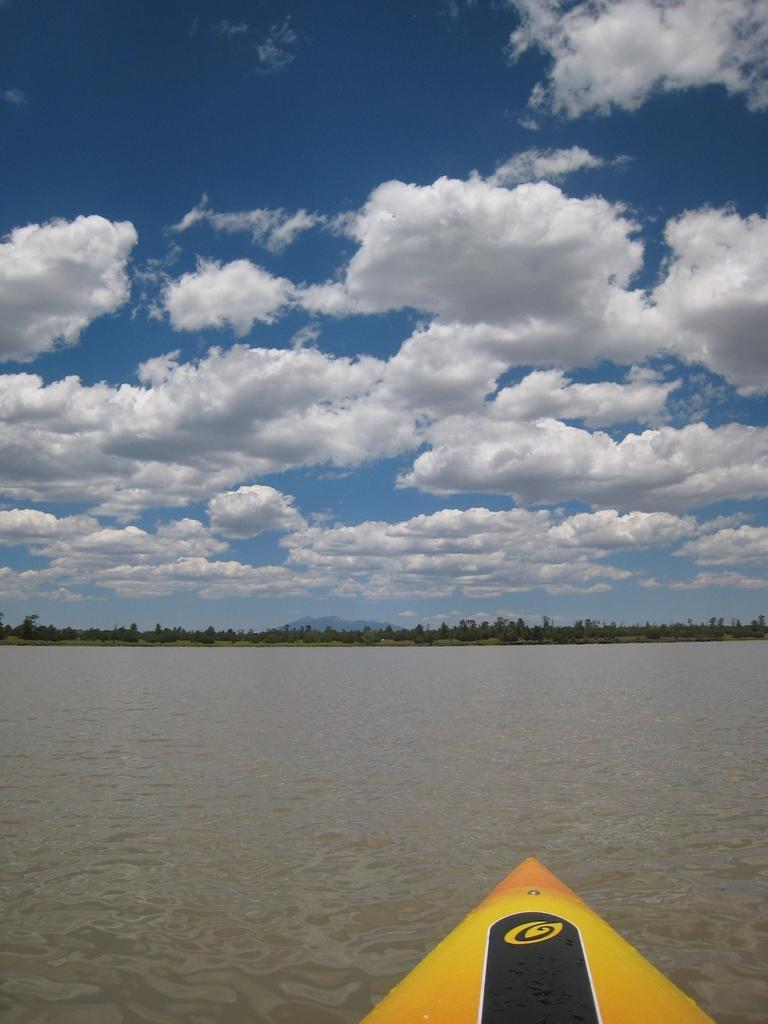In one or two sentences, can you explain what this image depicts? In this image we can see there is a water, trees and it looks like a boat. And at the top there is a cloudy sky. 